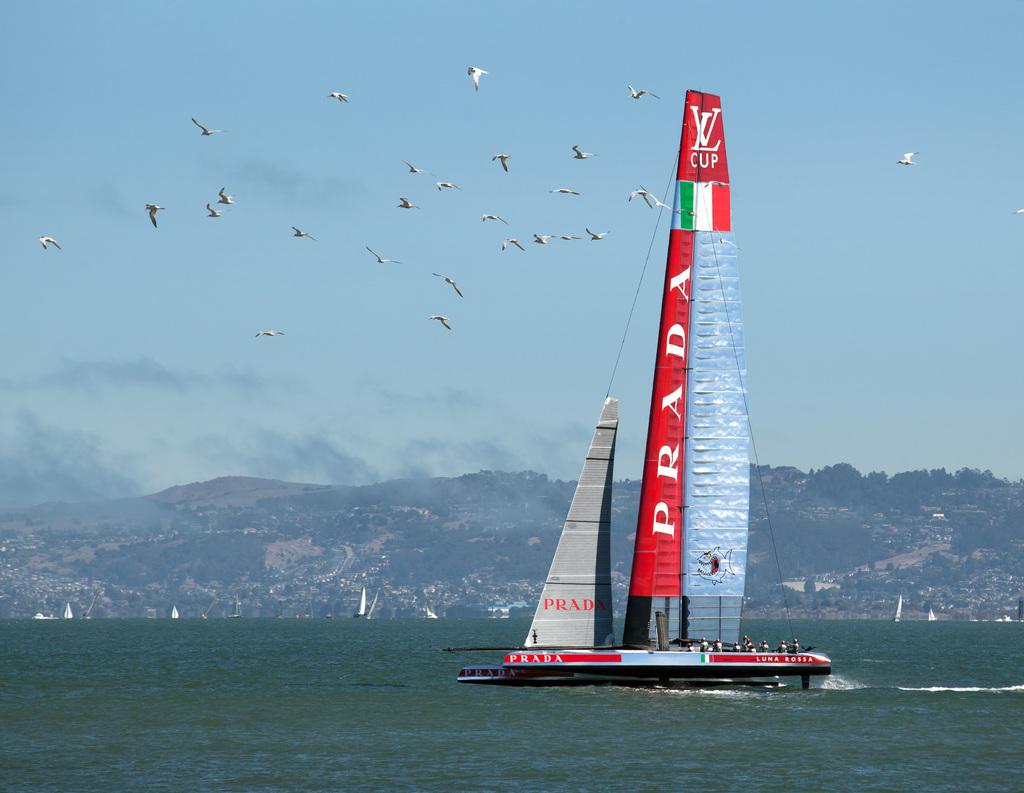What brand is advertised on this boat?
Give a very brief answer. Prada. What name is displayed vertically on the mast of the sailboat?
Your answer should be compact. Prada. 